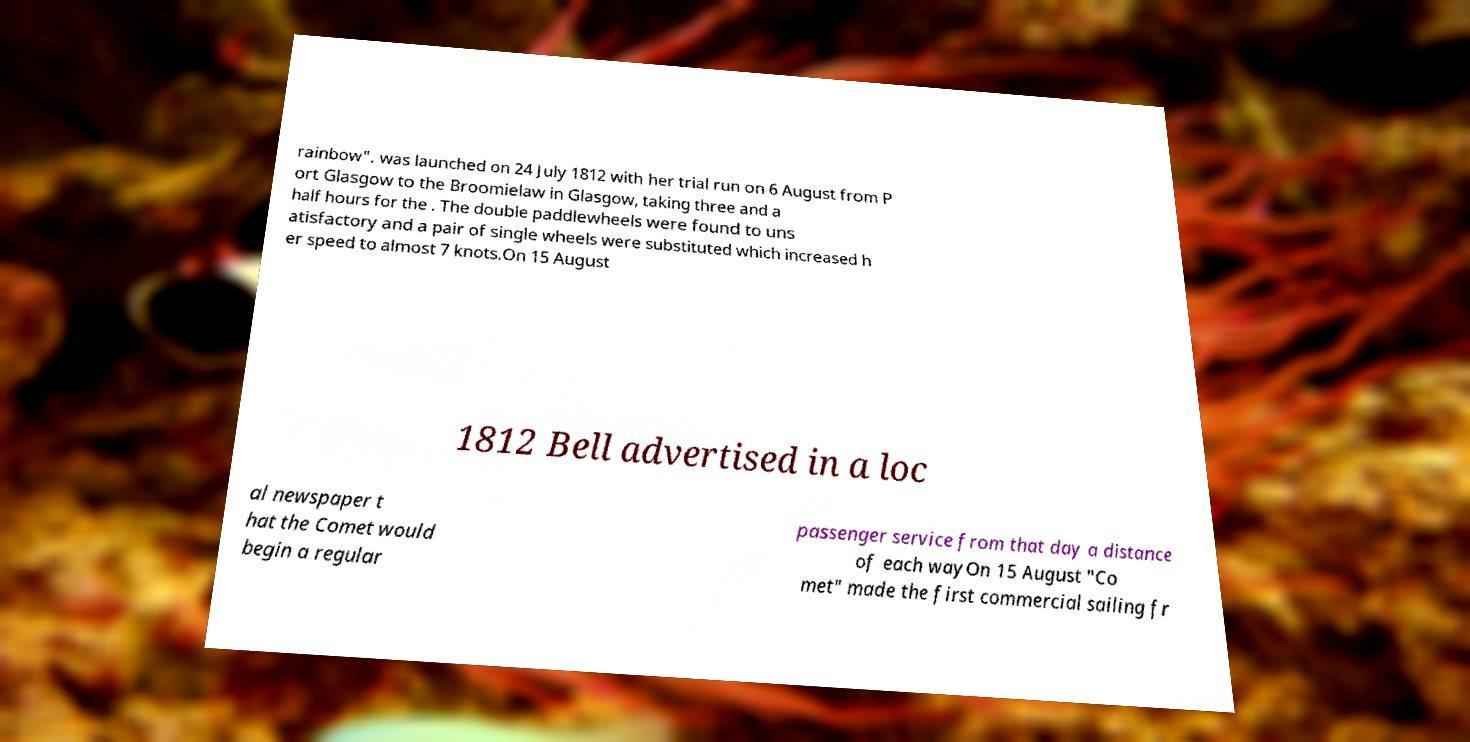Please identify and transcribe the text found in this image. rainbow". was launched on 24 July 1812 with her trial run on 6 August from P ort Glasgow to the Broomielaw in Glasgow, taking three and a half hours for the . The double paddlewheels were found to uns atisfactory and a pair of single wheels were substituted which increased h er speed to almost 7 knots.On 15 August 1812 Bell advertised in a loc al newspaper t hat the Comet would begin a regular passenger service from that day a distance of each wayOn 15 August "Co met" made the first commercial sailing fr 